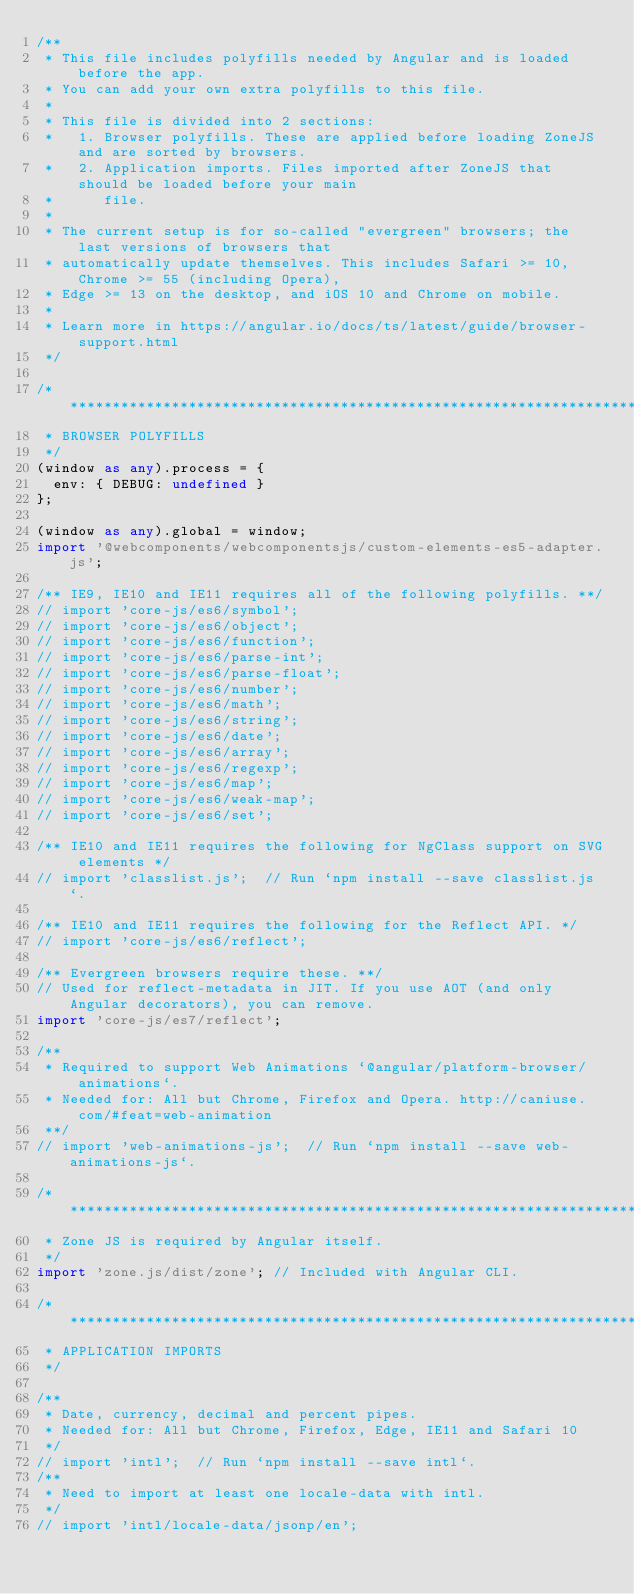<code> <loc_0><loc_0><loc_500><loc_500><_TypeScript_>/**
 * This file includes polyfills needed by Angular and is loaded before the app.
 * You can add your own extra polyfills to this file.
 *
 * This file is divided into 2 sections:
 *   1. Browser polyfills. These are applied before loading ZoneJS and are sorted by browsers.
 *   2. Application imports. Files imported after ZoneJS that should be loaded before your main
 *      file.
 *
 * The current setup is for so-called "evergreen" browsers; the last versions of browsers that
 * automatically update themselves. This includes Safari >= 10, Chrome >= 55 (including Opera),
 * Edge >= 13 on the desktop, and iOS 10 and Chrome on mobile.
 *
 * Learn more in https://angular.io/docs/ts/latest/guide/browser-support.html
 */

/***************************************************************************************************
 * BROWSER POLYFILLS
 */
(window as any).process = {
	env: { DEBUG: undefined }
};

(window as any).global = window;
import '@webcomponents/webcomponentsjs/custom-elements-es5-adapter.js';

/** IE9, IE10 and IE11 requires all of the following polyfills. **/
// import 'core-js/es6/symbol';
// import 'core-js/es6/object';
// import 'core-js/es6/function';
// import 'core-js/es6/parse-int';
// import 'core-js/es6/parse-float';
// import 'core-js/es6/number';
// import 'core-js/es6/math';
// import 'core-js/es6/string';
// import 'core-js/es6/date';
// import 'core-js/es6/array';
// import 'core-js/es6/regexp';
// import 'core-js/es6/map';
// import 'core-js/es6/weak-map';
// import 'core-js/es6/set';

/** IE10 and IE11 requires the following for NgClass support on SVG elements */
// import 'classlist.js';  // Run `npm install --save classlist.js`.

/** IE10 and IE11 requires the following for the Reflect API. */
// import 'core-js/es6/reflect';

/** Evergreen browsers require these. **/
// Used for reflect-metadata in JIT. If you use AOT (and only Angular decorators), you can remove.
import 'core-js/es7/reflect';

/**
 * Required to support Web Animations `@angular/platform-browser/animations`.
 * Needed for: All but Chrome, Firefox and Opera. http://caniuse.com/#feat=web-animation
 **/
// import 'web-animations-js';  // Run `npm install --save web-animations-js`.

/***************************************************************************************************
 * Zone JS is required by Angular itself.
 */
import 'zone.js/dist/zone'; // Included with Angular CLI.

/***************************************************************************************************
 * APPLICATION IMPORTS
 */

/**
 * Date, currency, decimal and percent pipes.
 * Needed for: All but Chrome, Firefox, Edge, IE11 and Safari 10
 */
// import 'intl';  // Run `npm install --save intl`.
/**
 * Need to import at least one locale-data with intl.
 */
// import 'intl/locale-data/jsonp/en';
</code> 